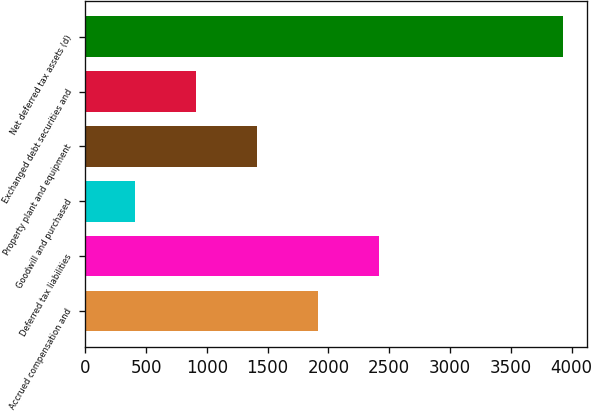Convert chart to OTSL. <chart><loc_0><loc_0><loc_500><loc_500><bar_chart><fcel>Accrued compensation and<fcel>Deferred tax liabilities<fcel>Goodwill and purchased<fcel>Property plant and equipment<fcel>Exchanged debt securities and<fcel>Net deferred tax assets (d)<nl><fcel>1913<fcel>2414<fcel>410<fcel>1412<fcel>911<fcel>3933<nl></chart> 